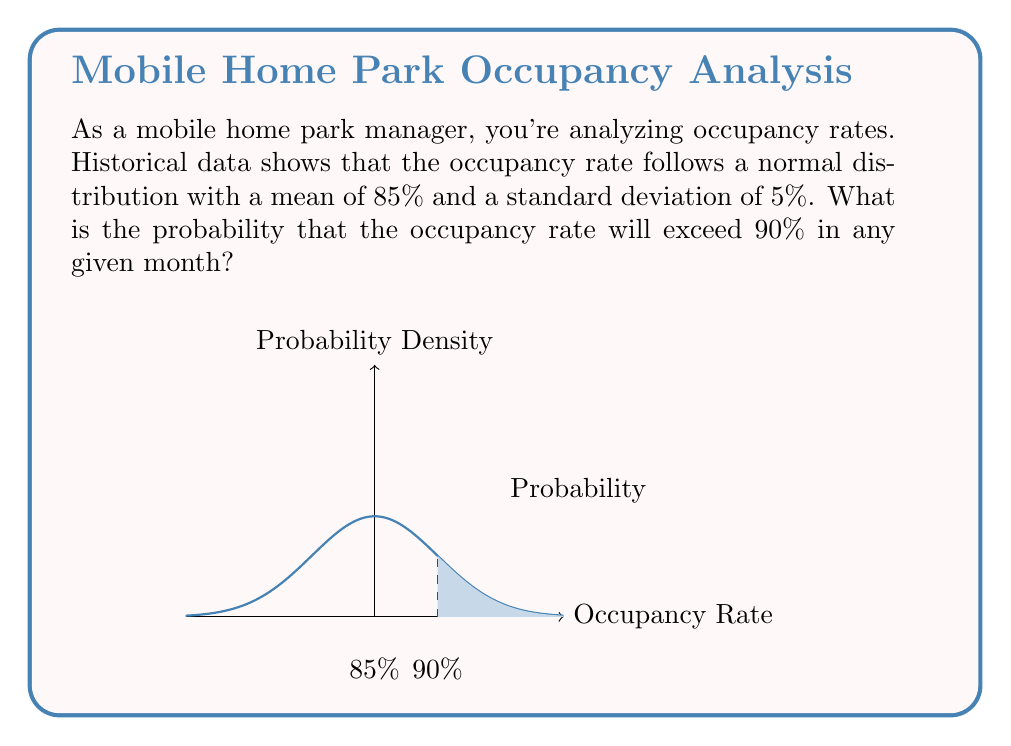Provide a solution to this math problem. To solve this problem, we'll use the properties of the normal distribution and the z-score formula.

1) First, we need to calculate the z-score for 90% occupancy:

   $z = \frac{x - \mu}{\sigma}$

   Where:
   $x = 90$ (the threshold we're interested in)
   $\mu = 85$ (the mean occupancy rate)
   $\sigma = 5$ (the standard deviation)

2) Plugging in these values:

   $z = \frac{90 - 85}{5} = 1$

3) Now we need to find the probability of a z-score greater than 1. This is equivalent to the area under the standard normal curve to the right of z = 1.

4) Using a standard normal table or calculator, we can find that:

   $P(Z > 1) = 0.1587$

5) Therefore, the probability of the occupancy rate exceeding 90% is 0.1587 or about 15.87%.
Answer: 0.1587 